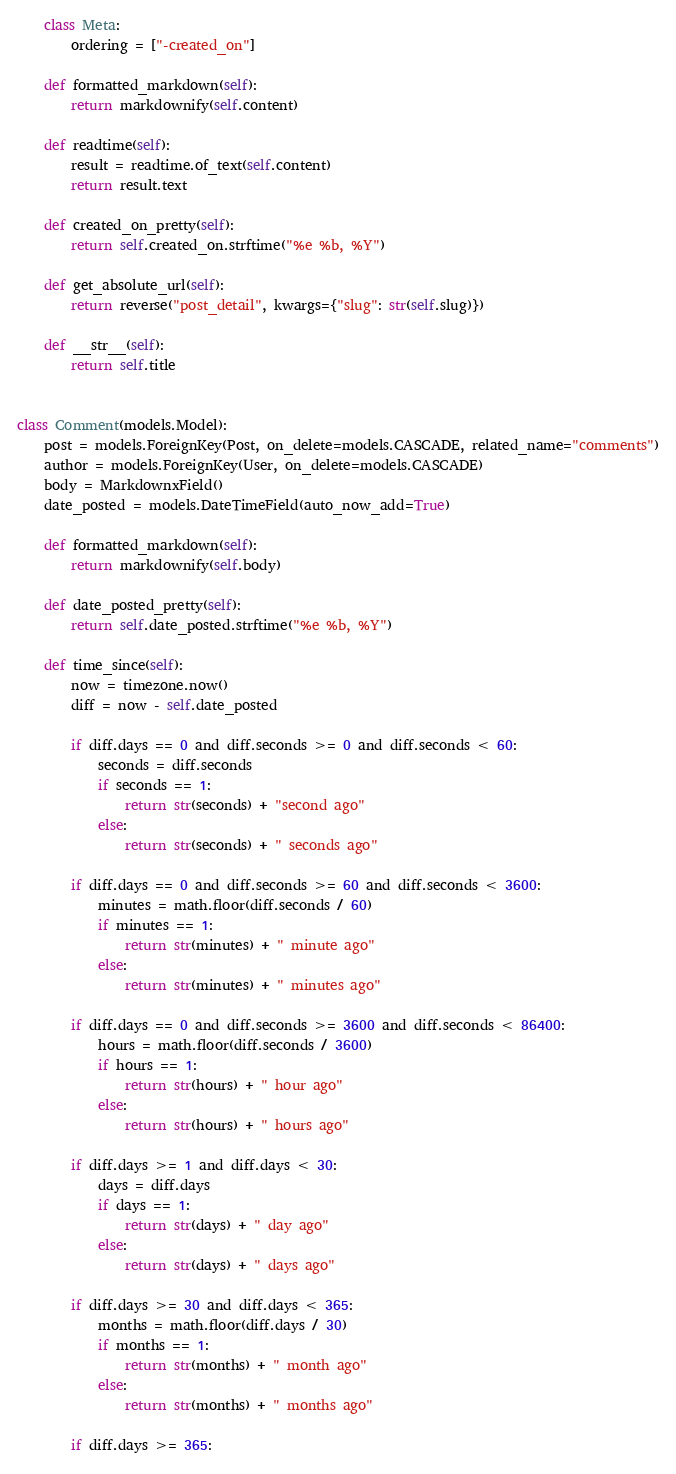<code> <loc_0><loc_0><loc_500><loc_500><_Python_>    class Meta:
        ordering = ["-created_on"]

    def formatted_markdown(self):
        return markdownify(self.content)

    def readtime(self):
        result = readtime.of_text(self.content)
        return result.text

    def created_on_pretty(self):
        return self.created_on.strftime("%e %b, %Y")

    def get_absolute_url(self):
        return reverse("post_detail", kwargs={"slug": str(self.slug)})

    def __str__(self):
        return self.title


class Comment(models.Model):
    post = models.ForeignKey(Post, on_delete=models.CASCADE, related_name="comments")
    author = models.ForeignKey(User, on_delete=models.CASCADE)
    body = MarkdownxField()
    date_posted = models.DateTimeField(auto_now_add=True)

    def formatted_markdown(self):
        return markdownify(self.body)

    def date_posted_pretty(self):
        return self.date_posted.strftime("%e %b, %Y")

    def time_since(self):
        now = timezone.now()
        diff = now - self.date_posted

        if diff.days == 0 and diff.seconds >= 0 and diff.seconds < 60:
            seconds = diff.seconds
            if seconds == 1:
                return str(seconds) + "second ago"
            else:
                return str(seconds) + " seconds ago"

        if diff.days == 0 and diff.seconds >= 60 and diff.seconds < 3600:
            minutes = math.floor(diff.seconds / 60)
            if minutes == 1:
                return str(minutes) + " minute ago"
            else:
                return str(minutes) + " minutes ago"

        if diff.days == 0 and diff.seconds >= 3600 and diff.seconds < 86400:
            hours = math.floor(diff.seconds / 3600)
            if hours == 1:
                return str(hours) + " hour ago"
            else:
                return str(hours) + " hours ago"

        if diff.days >= 1 and diff.days < 30:
            days = diff.days
            if days == 1:
                return str(days) + " day ago"
            else:
                return str(days) + " days ago"

        if diff.days >= 30 and diff.days < 365:
            months = math.floor(diff.days / 30)
            if months == 1:
                return str(months) + " month ago"
            else:
                return str(months) + " months ago"

        if diff.days >= 365:</code> 